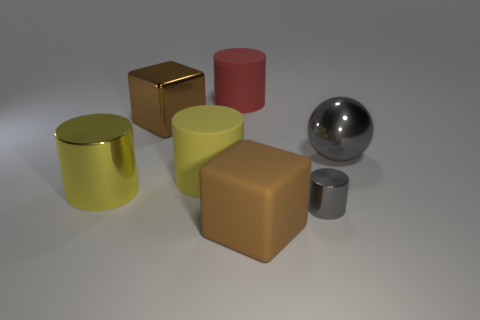Is there any other thing that is the same size as the gray cylinder?
Offer a terse response. No. How many other objects are the same size as the red rubber cylinder?
Ensure brevity in your answer.  5. Do the large metallic block and the big matte block have the same color?
Keep it short and to the point. Yes. There is a large yellow cylinder that is to the right of the brown block left of the brown matte object; what number of big brown matte cubes are behind it?
Offer a very short reply. 0. There is a red cylinder right of the large yellow object to the right of the big brown metal block; what is its material?
Offer a very short reply. Rubber. Are there any other red things that have the same shape as the small thing?
Your response must be concise. Yes. What color is the metallic ball that is the same size as the yellow metal object?
Give a very brief answer. Gray. How many things are either big metallic objects to the left of the yellow rubber thing or cylinders that are behind the gray metal ball?
Give a very brief answer. 3. How many things are metallic cylinders or matte cubes?
Give a very brief answer. 3. There is a cylinder that is both right of the large yellow shiny cylinder and left of the red matte cylinder; what is its size?
Provide a succinct answer. Large. 